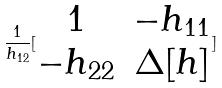<formula> <loc_0><loc_0><loc_500><loc_500>\frac { 1 } { h _ { 1 2 } } [ \begin{matrix} 1 & - h _ { 1 1 } \\ - h _ { 2 2 } & \Delta [ h ] \end{matrix} ]</formula> 